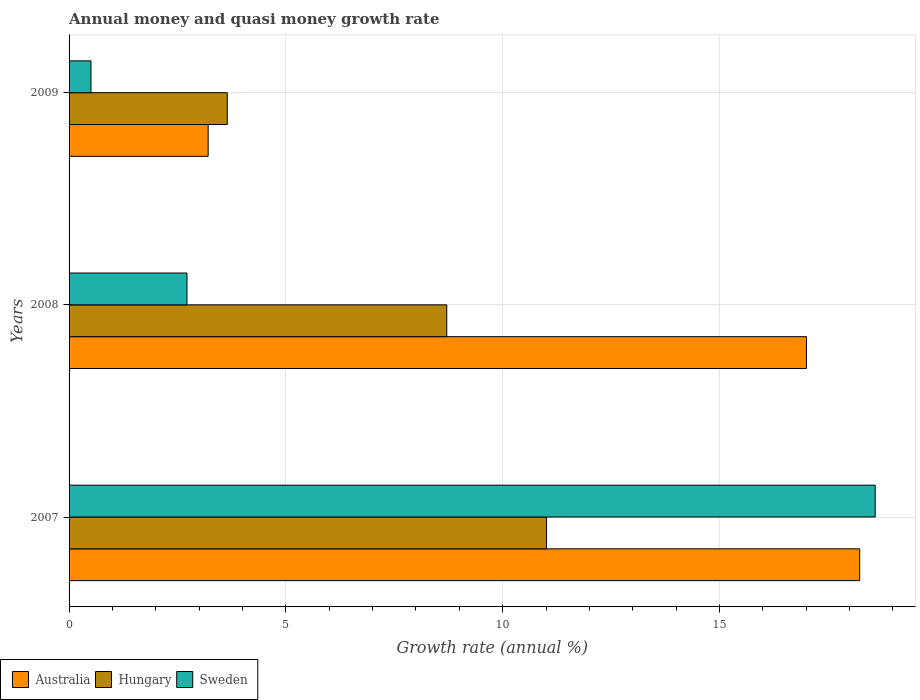How many different coloured bars are there?
Your answer should be very brief. 3. How many groups of bars are there?
Provide a succinct answer. 3. Are the number of bars per tick equal to the number of legend labels?
Offer a very short reply. Yes. How many bars are there on the 1st tick from the bottom?
Provide a short and direct response. 3. What is the growth rate in Hungary in 2008?
Offer a very short reply. 8.71. Across all years, what is the maximum growth rate in Australia?
Ensure brevity in your answer.  18.23. Across all years, what is the minimum growth rate in Australia?
Your answer should be compact. 3.21. In which year was the growth rate in Hungary minimum?
Offer a terse response. 2009. What is the total growth rate in Hungary in the graph?
Your response must be concise. 23.37. What is the difference between the growth rate in Sweden in 2007 and that in 2009?
Your answer should be compact. 18.08. What is the difference between the growth rate in Hungary in 2008 and the growth rate in Sweden in 2007?
Your answer should be compact. -9.88. What is the average growth rate in Hungary per year?
Keep it short and to the point. 7.79. In the year 2009, what is the difference between the growth rate in Sweden and growth rate in Australia?
Offer a terse response. -2.7. What is the ratio of the growth rate in Australia in 2008 to that in 2009?
Your answer should be very brief. 5.3. Is the growth rate in Hungary in 2008 less than that in 2009?
Your answer should be compact. No. What is the difference between the highest and the second highest growth rate in Australia?
Give a very brief answer. 1.23. What is the difference between the highest and the lowest growth rate in Australia?
Provide a succinct answer. 15.03. In how many years, is the growth rate in Sweden greater than the average growth rate in Sweden taken over all years?
Give a very brief answer. 1. Is the sum of the growth rate in Hungary in 2008 and 2009 greater than the maximum growth rate in Australia across all years?
Provide a succinct answer. No. What does the 3rd bar from the top in 2008 represents?
Provide a short and direct response. Australia. What does the 3rd bar from the bottom in 2009 represents?
Provide a succinct answer. Sweden. Is it the case that in every year, the sum of the growth rate in Hungary and growth rate in Sweden is greater than the growth rate in Australia?
Make the answer very short. No. How many years are there in the graph?
Provide a succinct answer. 3. Are the values on the major ticks of X-axis written in scientific E-notation?
Your answer should be compact. No. Does the graph contain grids?
Make the answer very short. Yes. How many legend labels are there?
Make the answer very short. 3. What is the title of the graph?
Keep it short and to the point. Annual money and quasi money growth rate. What is the label or title of the X-axis?
Your answer should be compact. Growth rate (annual %). What is the label or title of the Y-axis?
Provide a short and direct response. Years. What is the Growth rate (annual %) of Australia in 2007?
Keep it short and to the point. 18.23. What is the Growth rate (annual %) of Hungary in 2007?
Provide a succinct answer. 11.01. What is the Growth rate (annual %) in Sweden in 2007?
Provide a short and direct response. 18.59. What is the Growth rate (annual %) in Australia in 2008?
Provide a succinct answer. 17. What is the Growth rate (annual %) in Hungary in 2008?
Your answer should be compact. 8.71. What is the Growth rate (annual %) of Sweden in 2008?
Your answer should be very brief. 2.72. What is the Growth rate (annual %) of Australia in 2009?
Provide a short and direct response. 3.21. What is the Growth rate (annual %) of Hungary in 2009?
Ensure brevity in your answer.  3.65. What is the Growth rate (annual %) in Sweden in 2009?
Your answer should be compact. 0.51. Across all years, what is the maximum Growth rate (annual %) in Australia?
Make the answer very short. 18.23. Across all years, what is the maximum Growth rate (annual %) of Hungary?
Give a very brief answer. 11.01. Across all years, what is the maximum Growth rate (annual %) in Sweden?
Keep it short and to the point. 18.59. Across all years, what is the minimum Growth rate (annual %) in Australia?
Offer a very short reply. 3.21. Across all years, what is the minimum Growth rate (annual %) of Hungary?
Give a very brief answer. 3.65. Across all years, what is the minimum Growth rate (annual %) in Sweden?
Offer a very short reply. 0.51. What is the total Growth rate (annual %) in Australia in the graph?
Provide a short and direct response. 38.45. What is the total Growth rate (annual %) of Hungary in the graph?
Your answer should be compact. 23.37. What is the total Growth rate (annual %) in Sweden in the graph?
Provide a short and direct response. 21.81. What is the difference between the Growth rate (annual %) in Australia in 2007 and that in 2008?
Offer a terse response. 1.23. What is the difference between the Growth rate (annual %) in Hungary in 2007 and that in 2008?
Your response must be concise. 2.3. What is the difference between the Growth rate (annual %) in Sweden in 2007 and that in 2008?
Offer a terse response. 15.87. What is the difference between the Growth rate (annual %) of Australia in 2007 and that in 2009?
Offer a terse response. 15.03. What is the difference between the Growth rate (annual %) of Hungary in 2007 and that in 2009?
Offer a very short reply. 7.36. What is the difference between the Growth rate (annual %) in Sweden in 2007 and that in 2009?
Make the answer very short. 18.08. What is the difference between the Growth rate (annual %) of Australia in 2008 and that in 2009?
Provide a short and direct response. 13.8. What is the difference between the Growth rate (annual %) in Hungary in 2008 and that in 2009?
Provide a short and direct response. 5.06. What is the difference between the Growth rate (annual %) of Sweden in 2008 and that in 2009?
Give a very brief answer. 2.21. What is the difference between the Growth rate (annual %) of Australia in 2007 and the Growth rate (annual %) of Hungary in 2008?
Offer a very short reply. 9.52. What is the difference between the Growth rate (annual %) of Australia in 2007 and the Growth rate (annual %) of Sweden in 2008?
Keep it short and to the point. 15.51. What is the difference between the Growth rate (annual %) in Hungary in 2007 and the Growth rate (annual %) in Sweden in 2008?
Give a very brief answer. 8.29. What is the difference between the Growth rate (annual %) in Australia in 2007 and the Growth rate (annual %) in Hungary in 2009?
Keep it short and to the point. 14.58. What is the difference between the Growth rate (annual %) in Australia in 2007 and the Growth rate (annual %) in Sweden in 2009?
Give a very brief answer. 17.73. What is the difference between the Growth rate (annual %) of Hungary in 2007 and the Growth rate (annual %) of Sweden in 2009?
Provide a succinct answer. 10.51. What is the difference between the Growth rate (annual %) in Australia in 2008 and the Growth rate (annual %) in Hungary in 2009?
Your response must be concise. 13.36. What is the difference between the Growth rate (annual %) in Australia in 2008 and the Growth rate (annual %) in Sweden in 2009?
Give a very brief answer. 16.5. What is the difference between the Growth rate (annual %) of Hungary in 2008 and the Growth rate (annual %) of Sweden in 2009?
Provide a succinct answer. 8.2. What is the average Growth rate (annual %) of Australia per year?
Offer a very short reply. 12.82. What is the average Growth rate (annual %) of Hungary per year?
Make the answer very short. 7.79. What is the average Growth rate (annual %) of Sweden per year?
Provide a short and direct response. 7.27. In the year 2007, what is the difference between the Growth rate (annual %) in Australia and Growth rate (annual %) in Hungary?
Keep it short and to the point. 7.22. In the year 2007, what is the difference between the Growth rate (annual %) of Australia and Growth rate (annual %) of Sweden?
Offer a terse response. -0.36. In the year 2007, what is the difference between the Growth rate (annual %) in Hungary and Growth rate (annual %) in Sweden?
Offer a terse response. -7.58. In the year 2008, what is the difference between the Growth rate (annual %) in Australia and Growth rate (annual %) in Hungary?
Provide a short and direct response. 8.3. In the year 2008, what is the difference between the Growth rate (annual %) of Australia and Growth rate (annual %) of Sweden?
Offer a terse response. 14.29. In the year 2008, what is the difference between the Growth rate (annual %) of Hungary and Growth rate (annual %) of Sweden?
Your answer should be compact. 5.99. In the year 2009, what is the difference between the Growth rate (annual %) of Australia and Growth rate (annual %) of Hungary?
Your answer should be very brief. -0.44. In the year 2009, what is the difference between the Growth rate (annual %) of Australia and Growth rate (annual %) of Sweden?
Provide a succinct answer. 2.7. In the year 2009, what is the difference between the Growth rate (annual %) of Hungary and Growth rate (annual %) of Sweden?
Provide a succinct answer. 3.14. What is the ratio of the Growth rate (annual %) of Australia in 2007 to that in 2008?
Make the answer very short. 1.07. What is the ratio of the Growth rate (annual %) in Hungary in 2007 to that in 2008?
Keep it short and to the point. 1.26. What is the ratio of the Growth rate (annual %) of Sweden in 2007 to that in 2008?
Offer a terse response. 6.84. What is the ratio of the Growth rate (annual %) in Australia in 2007 to that in 2009?
Ensure brevity in your answer.  5.68. What is the ratio of the Growth rate (annual %) of Hungary in 2007 to that in 2009?
Give a very brief answer. 3.02. What is the ratio of the Growth rate (annual %) in Sweden in 2007 to that in 2009?
Ensure brevity in your answer.  36.8. What is the ratio of the Growth rate (annual %) in Australia in 2008 to that in 2009?
Offer a terse response. 5.3. What is the ratio of the Growth rate (annual %) of Hungary in 2008 to that in 2009?
Offer a very short reply. 2.39. What is the ratio of the Growth rate (annual %) in Sweden in 2008 to that in 2009?
Offer a very short reply. 5.38. What is the difference between the highest and the second highest Growth rate (annual %) in Australia?
Give a very brief answer. 1.23. What is the difference between the highest and the second highest Growth rate (annual %) of Hungary?
Offer a very short reply. 2.3. What is the difference between the highest and the second highest Growth rate (annual %) of Sweden?
Provide a short and direct response. 15.87. What is the difference between the highest and the lowest Growth rate (annual %) of Australia?
Provide a succinct answer. 15.03. What is the difference between the highest and the lowest Growth rate (annual %) of Hungary?
Your answer should be very brief. 7.36. What is the difference between the highest and the lowest Growth rate (annual %) in Sweden?
Offer a very short reply. 18.08. 